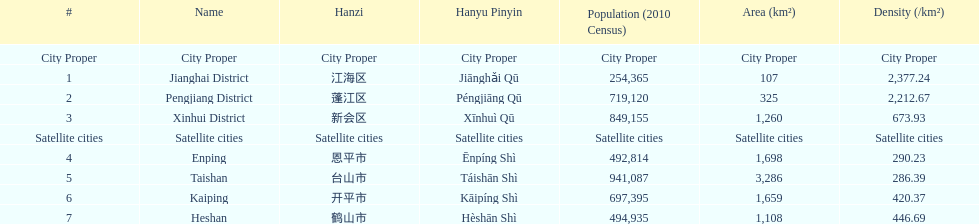What district has the largest population? Taishan. 